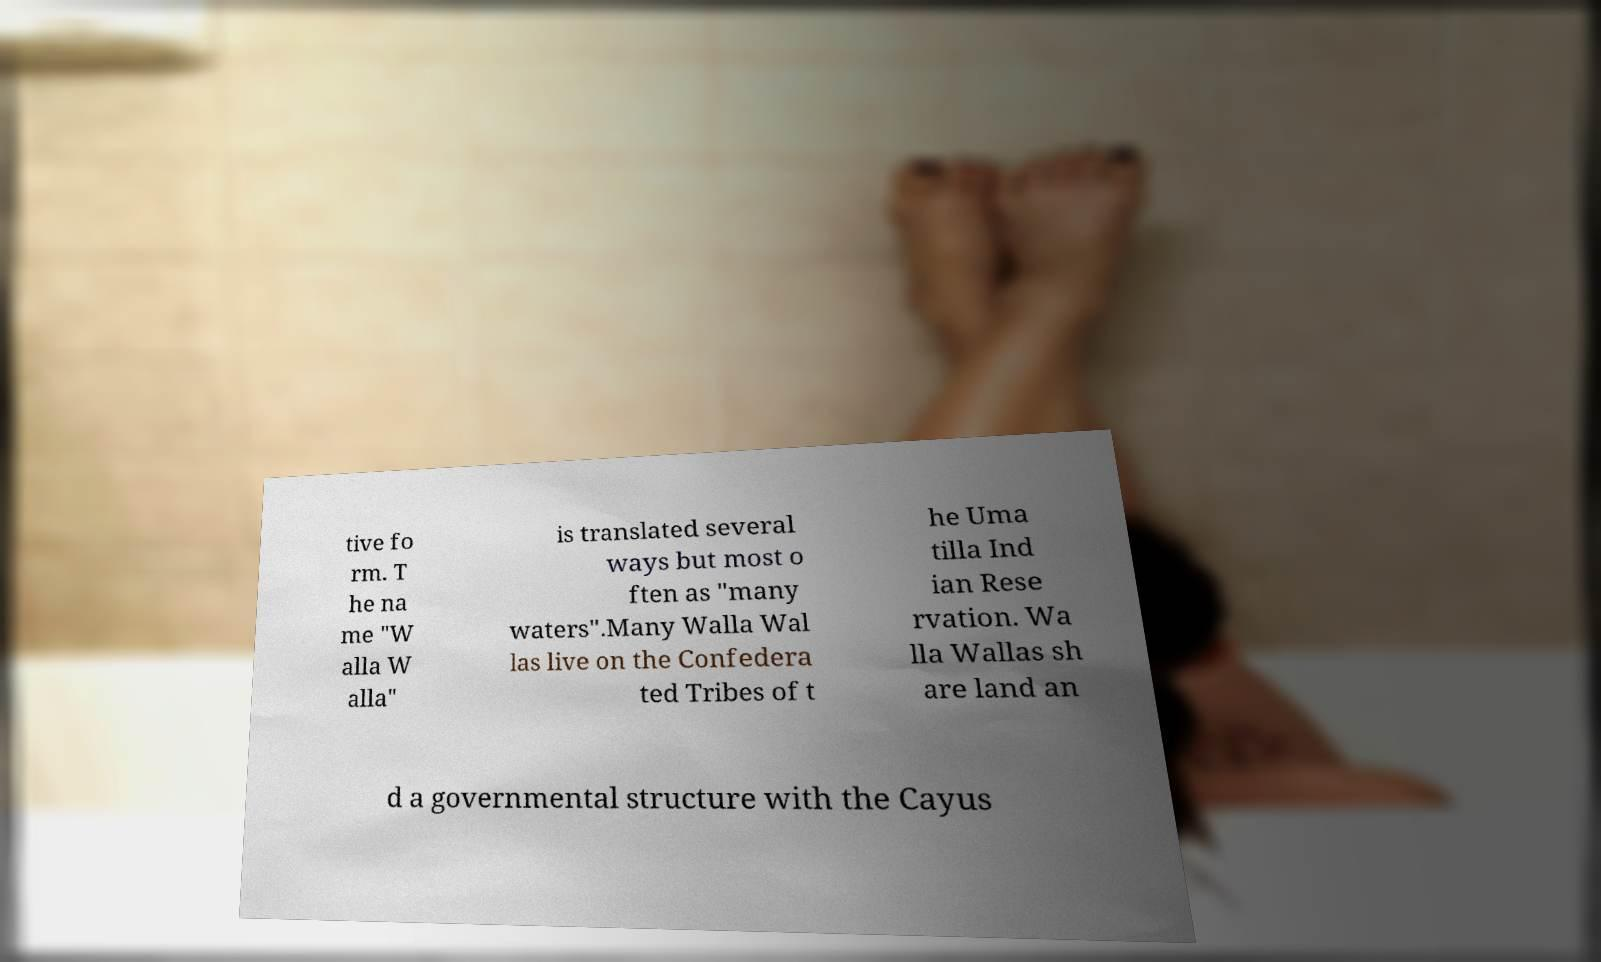Could you extract and type out the text from this image? tive fo rm. T he na me "W alla W alla" is translated several ways but most o ften as "many waters".Many Walla Wal las live on the Confedera ted Tribes of t he Uma tilla Ind ian Rese rvation. Wa lla Wallas sh are land an d a governmental structure with the Cayus 